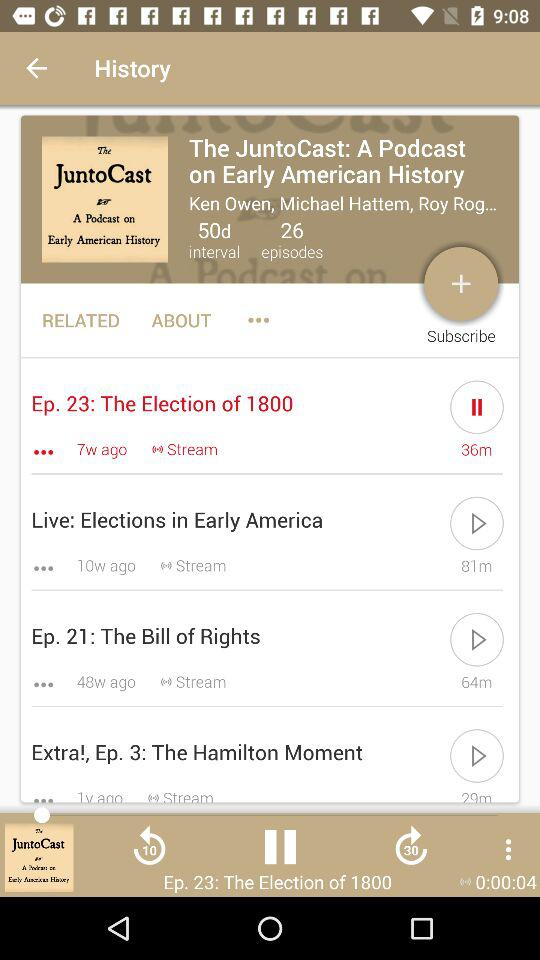What is the total number of intervals? The total number of intervals is "50d". 